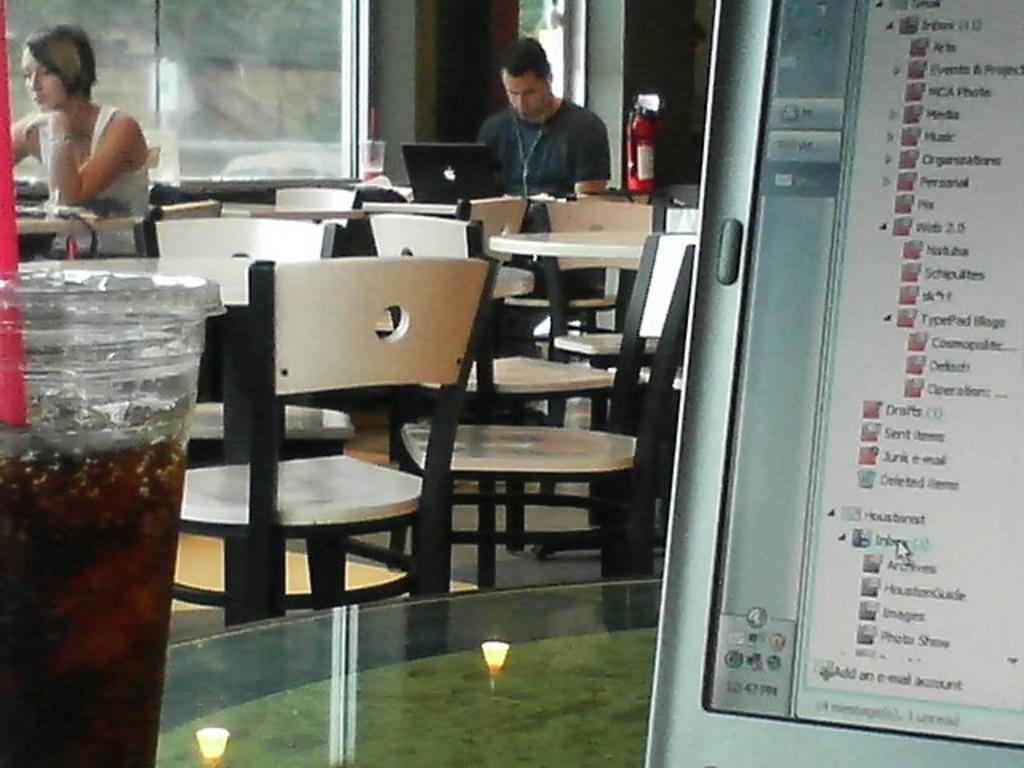Who are the people in the image? There is a woman and a guy in the image. What are they doing in the image? Both the woman and guy are sitting on chairs. Where might this image have been taken? The image appears to be inside a hotel. What can be seen on the right side of the image? There is a screen on the right side of the image. What is present on the left side of the image? There is a soft drink bottle on the left side of the image. What type of vegetable is being served on the plate in the image? There is no plate or vegetable present in the image. How many times does the queen appear in the image? There is no queen present in the image. 